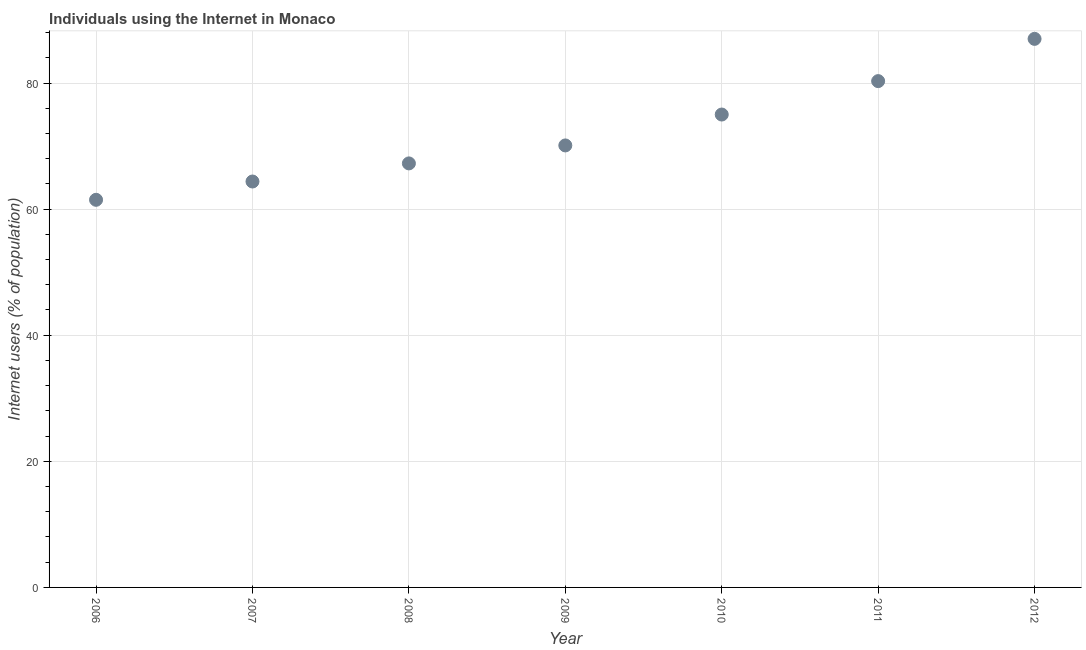Across all years, what is the maximum number of internet users?
Your response must be concise. 87. Across all years, what is the minimum number of internet users?
Your answer should be compact. 61.48. In which year was the number of internet users maximum?
Keep it short and to the point. 2012. In which year was the number of internet users minimum?
Offer a terse response. 2006. What is the sum of the number of internet users?
Keep it short and to the point. 505.5. What is the difference between the number of internet users in 2007 and 2012?
Make the answer very short. -22.62. What is the average number of internet users per year?
Give a very brief answer. 72.21. What is the median number of internet users?
Your response must be concise. 70.1. What is the ratio of the number of internet users in 2010 to that in 2012?
Provide a short and direct response. 0.86. Is the number of internet users in 2006 less than that in 2009?
Offer a very short reply. Yes. What is the difference between the highest and the second highest number of internet users?
Ensure brevity in your answer.  6.7. Is the sum of the number of internet users in 2010 and 2011 greater than the maximum number of internet users across all years?
Give a very brief answer. Yes. What is the difference between the highest and the lowest number of internet users?
Make the answer very short. 25.52. How many dotlines are there?
Ensure brevity in your answer.  1. How many years are there in the graph?
Offer a very short reply. 7. What is the difference between two consecutive major ticks on the Y-axis?
Your response must be concise. 20. Does the graph contain any zero values?
Make the answer very short. No. Does the graph contain grids?
Keep it short and to the point. Yes. What is the title of the graph?
Keep it short and to the point. Individuals using the Internet in Monaco. What is the label or title of the X-axis?
Offer a terse response. Year. What is the label or title of the Y-axis?
Provide a short and direct response. Internet users (% of population). What is the Internet users (% of population) in 2006?
Your answer should be very brief. 61.48. What is the Internet users (% of population) in 2007?
Your response must be concise. 64.38. What is the Internet users (% of population) in 2008?
Your answer should be very brief. 67.25. What is the Internet users (% of population) in 2009?
Offer a terse response. 70.1. What is the Internet users (% of population) in 2011?
Your answer should be very brief. 80.3. What is the Internet users (% of population) in 2012?
Keep it short and to the point. 87. What is the difference between the Internet users (% of population) in 2006 and 2007?
Give a very brief answer. -2.9. What is the difference between the Internet users (% of population) in 2006 and 2008?
Give a very brief answer. -5.77. What is the difference between the Internet users (% of population) in 2006 and 2009?
Give a very brief answer. -8.62. What is the difference between the Internet users (% of population) in 2006 and 2010?
Provide a short and direct response. -13.52. What is the difference between the Internet users (% of population) in 2006 and 2011?
Your answer should be compact. -18.82. What is the difference between the Internet users (% of population) in 2006 and 2012?
Keep it short and to the point. -25.52. What is the difference between the Internet users (% of population) in 2007 and 2008?
Give a very brief answer. -2.87. What is the difference between the Internet users (% of population) in 2007 and 2009?
Your answer should be compact. -5.72. What is the difference between the Internet users (% of population) in 2007 and 2010?
Offer a very short reply. -10.62. What is the difference between the Internet users (% of population) in 2007 and 2011?
Keep it short and to the point. -15.92. What is the difference between the Internet users (% of population) in 2007 and 2012?
Provide a succinct answer. -22.62. What is the difference between the Internet users (% of population) in 2008 and 2009?
Offer a very short reply. -2.85. What is the difference between the Internet users (% of population) in 2008 and 2010?
Offer a terse response. -7.75. What is the difference between the Internet users (% of population) in 2008 and 2011?
Ensure brevity in your answer.  -13.05. What is the difference between the Internet users (% of population) in 2008 and 2012?
Provide a short and direct response. -19.75. What is the difference between the Internet users (% of population) in 2009 and 2012?
Your answer should be compact. -16.9. What is the difference between the Internet users (% of population) in 2011 and 2012?
Keep it short and to the point. -6.7. What is the ratio of the Internet users (% of population) in 2006 to that in 2007?
Keep it short and to the point. 0.95. What is the ratio of the Internet users (% of population) in 2006 to that in 2008?
Your answer should be very brief. 0.91. What is the ratio of the Internet users (% of population) in 2006 to that in 2009?
Keep it short and to the point. 0.88. What is the ratio of the Internet users (% of population) in 2006 to that in 2010?
Provide a short and direct response. 0.82. What is the ratio of the Internet users (% of population) in 2006 to that in 2011?
Make the answer very short. 0.77. What is the ratio of the Internet users (% of population) in 2006 to that in 2012?
Make the answer very short. 0.71. What is the ratio of the Internet users (% of population) in 2007 to that in 2009?
Your answer should be compact. 0.92. What is the ratio of the Internet users (% of population) in 2007 to that in 2010?
Offer a terse response. 0.86. What is the ratio of the Internet users (% of population) in 2007 to that in 2011?
Make the answer very short. 0.8. What is the ratio of the Internet users (% of population) in 2007 to that in 2012?
Give a very brief answer. 0.74. What is the ratio of the Internet users (% of population) in 2008 to that in 2010?
Offer a very short reply. 0.9. What is the ratio of the Internet users (% of population) in 2008 to that in 2011?
Make the answer very short. 0.84. What is the ratio of the Internet users (% of population) in 2008 to that in 2012?
Offer a very short reply. 0.77. What is the ratio of the Internet users (% of population) in 2009 to that in 2010?
Provide a succinct answer. 0.94. What is the ratio of the Internet users (% of population) in 2009 to that in 2011?
Offer a terse response. 0.87. What is the ratio of the Internet users (% of population) in 2009 to that in 2012?
Provide a short and direct response. 0.81. What is the ratio of the Internet users (% of population) in 2010 to that in 2011?
Provide a short and direct response. 0.93. What is the ratio of the Internet users (% of population) in 2010 to that in 2012?
Offer a terse response. 0.86. What is the ratio of the Internet users (% of population) in 2011 to that in 2012?
Provide a short and direct response. 0.92. 